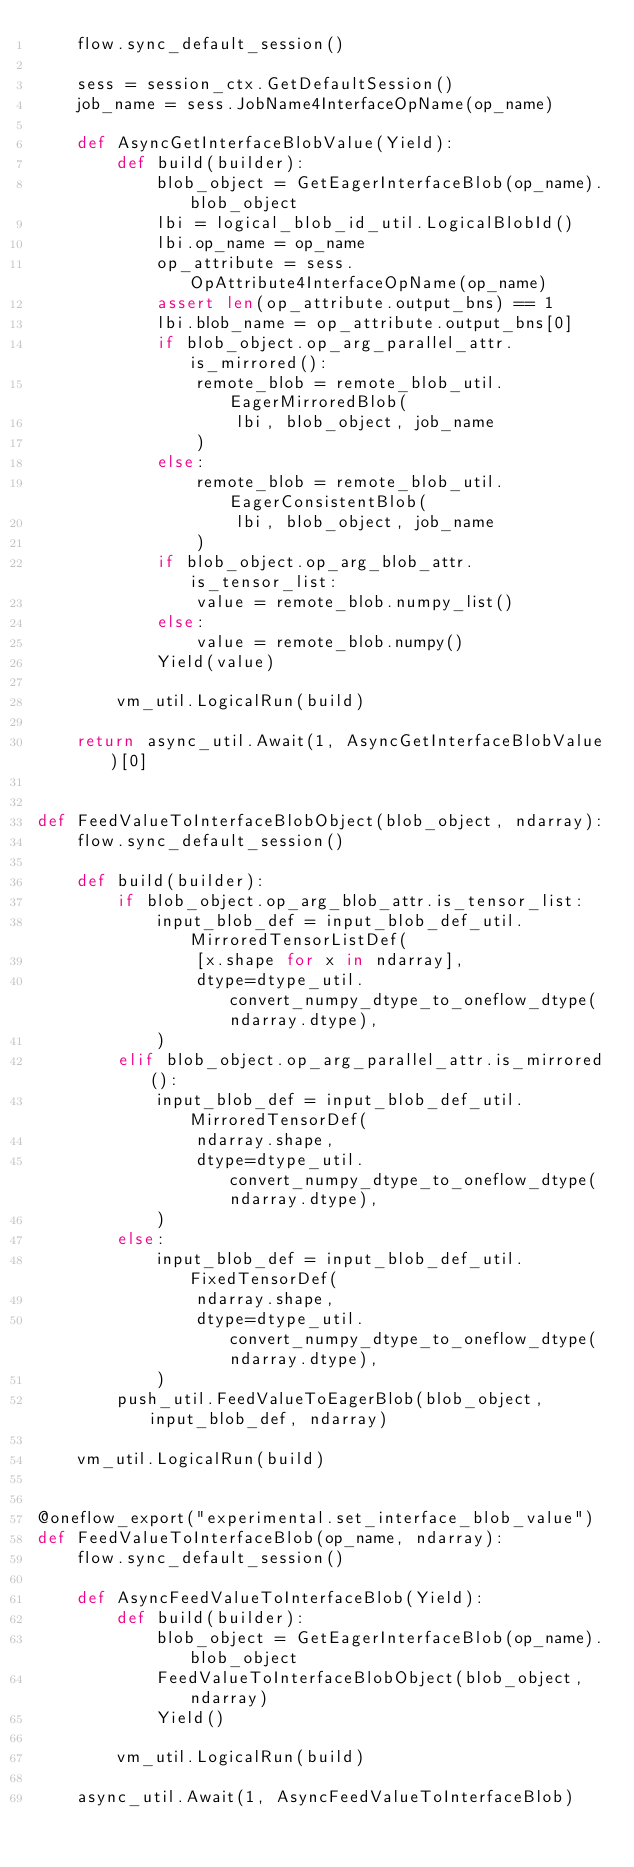<code> <loc_0><loc_0><loc_500><loc_500><_Python_>    flow.sync_default_session()

    sess = session_ctx.GetDefaultSession()
    job_name = sess.JobName4InterfaceOpName(op_name)

    def AsyncGetInterfaceBlobValue(Yield):
        def build(builder):
            blob_object = GetEagerInterfaceBlob(op_name).blob_object
            lbi = logical_blob_id_util.LogicalBlobId()
            lbi.op_name = op_name
            op_attribute = sess.OpAttribute4InterfaceOpName(op_name)
            assert len(op_attribute.output_bns) == 1
            lbi.blob_name = op_attribute.output_bns[0]
            if blob_object.op_arg_parallel_attr.is_mirrored():
                remote_blob = remote_blob_util.EagerMirroredBlob(
                    lbi, blob_object, job_name
                )
            else:
                remote_blob = remote_blob_util.EagerConsistentBlob(
                    lbi, blob_object, job_name
                )
            if blob_object.op_arg_blob_attr.is_tensor_list:
                value = remote_blob.numpy_list()
            else:
                value = remote_blob.numpy()
            Yield(value)

        vm_util.LogicalRun(build)

    return async_util.Await(1, AsyncGetInterfaceBlobValue)[0]


def FeedValueToInterfaceBlobObject(blob_object, ndarray):
    flow.sync_default_session()

    def build(builder):
        if blob_object.op_arg_blob_attr.is_tensor_list:
            input_blob_def = input_blob_def_util.MirroredTensorListDef(
                [x.shape for x in ndarray],
                dtype=dtype_util.convert_numpy_dtype_to_oneflow_dtype(ndarray.dtype),
            )
        elif blob_object.op_arg_parallel_attr.is_mirrored():
            input_blob_def = input_blob_def_util.MirroredTensorDef(
                ndarray.shape,
                dtype=dtype_util.convert_numpy_dtype_to_oneflow_dtype(ndarray.dtype),
            )
        else:
            input_blob_def = input_blob_def_util.FixedTensorDef(
                ndarray.shape,
                dtype=dtype_util.convert_numpy_dtype_to_oneflow_dtype(ndarray.dtype),
            )
        push_util.FeedValueToEagerBlob(blob_object, input_blob_def, ndarray)

    vm_util.LogicalRun(build)


@oneflow_export("experimental.set_interface_blob_value")
def FeedValueToInterfaceBlob(op_name, ndarray):
    flow.sync_default_session()

    def AsyncFeedValueToInterfaceBlob(Yield):
        def build(builder):
            blob_object = GetEagerInterfaceBlob(op_name).blob_object
            FeedValueToInterfaceBlobObject(blob_object, ndarray)
            Yield()

        vm_util.LogicalRun(build)

    async_util.Await(1, AsyncFeedValueToInterfaceBlob)
</code> 